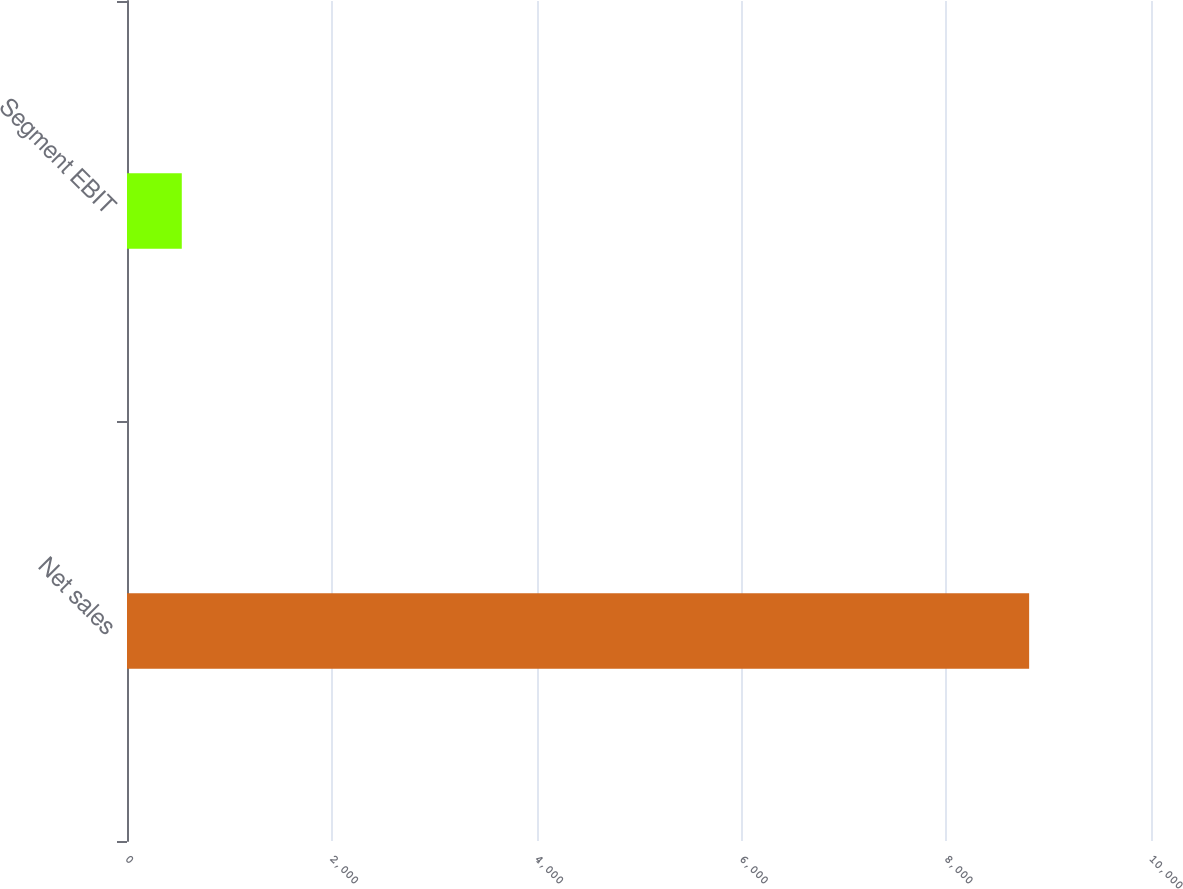Convert chart to OTSL. <chart><loc_0><loc_0><loc_500><loc_500><bar_chart><fcel>Net sales<fcel>Segment EBIT<nl><fcel>8810<fcel>535<nl></chart> 